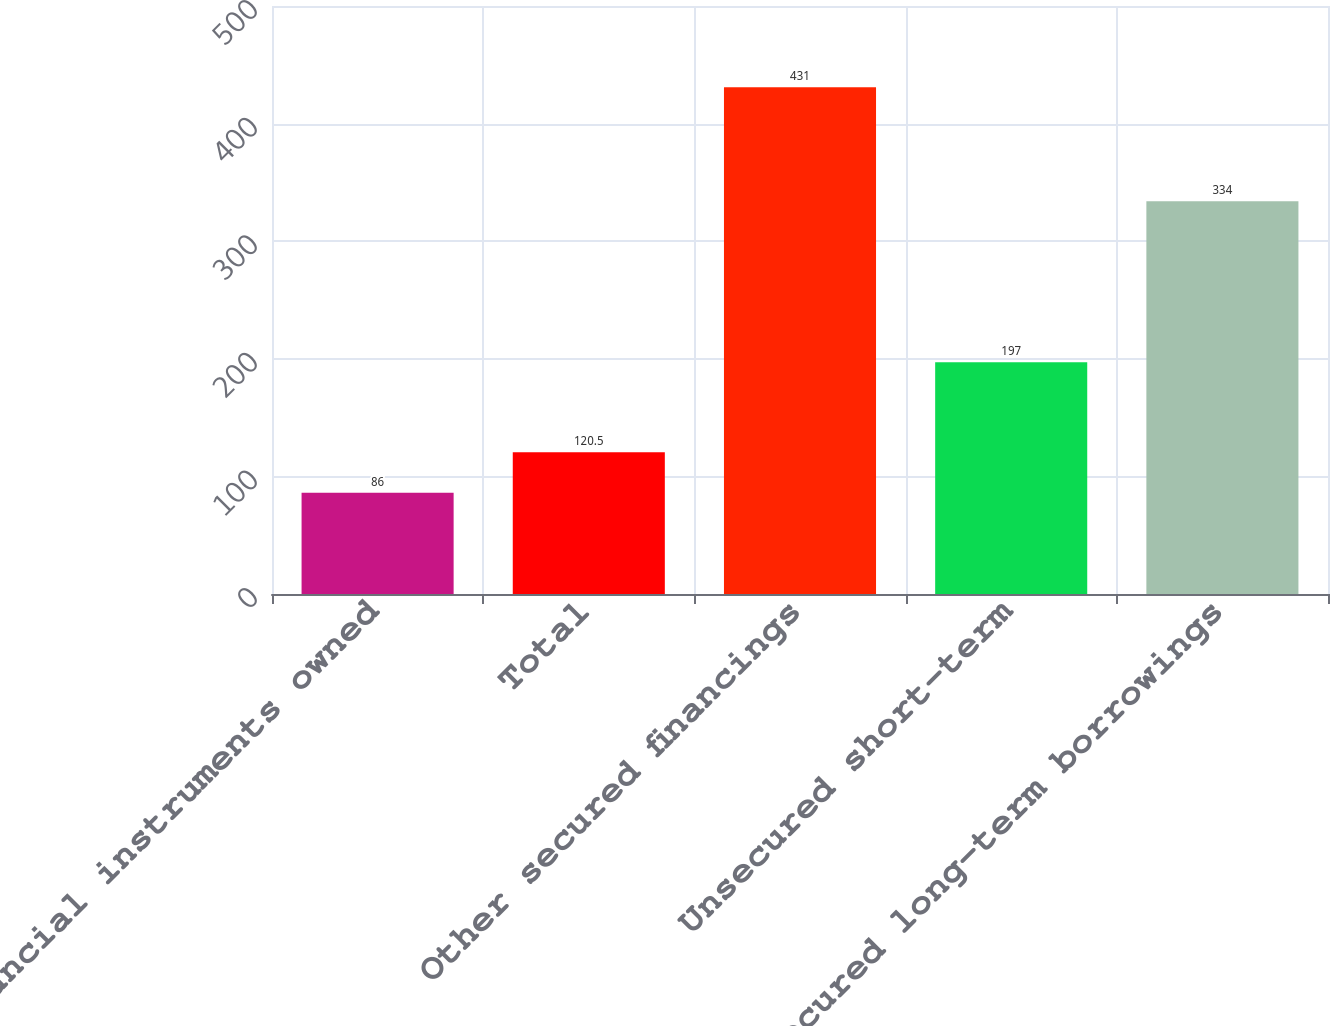Convert chart. <chart><loc_0><loc_0><loc_500><loc_500><bar_chart><fcel>Financial instruments owned<fcel>Total<fcel>Other secured financings<fcel>Unsecured short-term<fcel>Unsecured long-term borrowings<nl><fcel>86<fcel>120.5<fcel>431<fcel>197<fcel>334<nl></chart> 